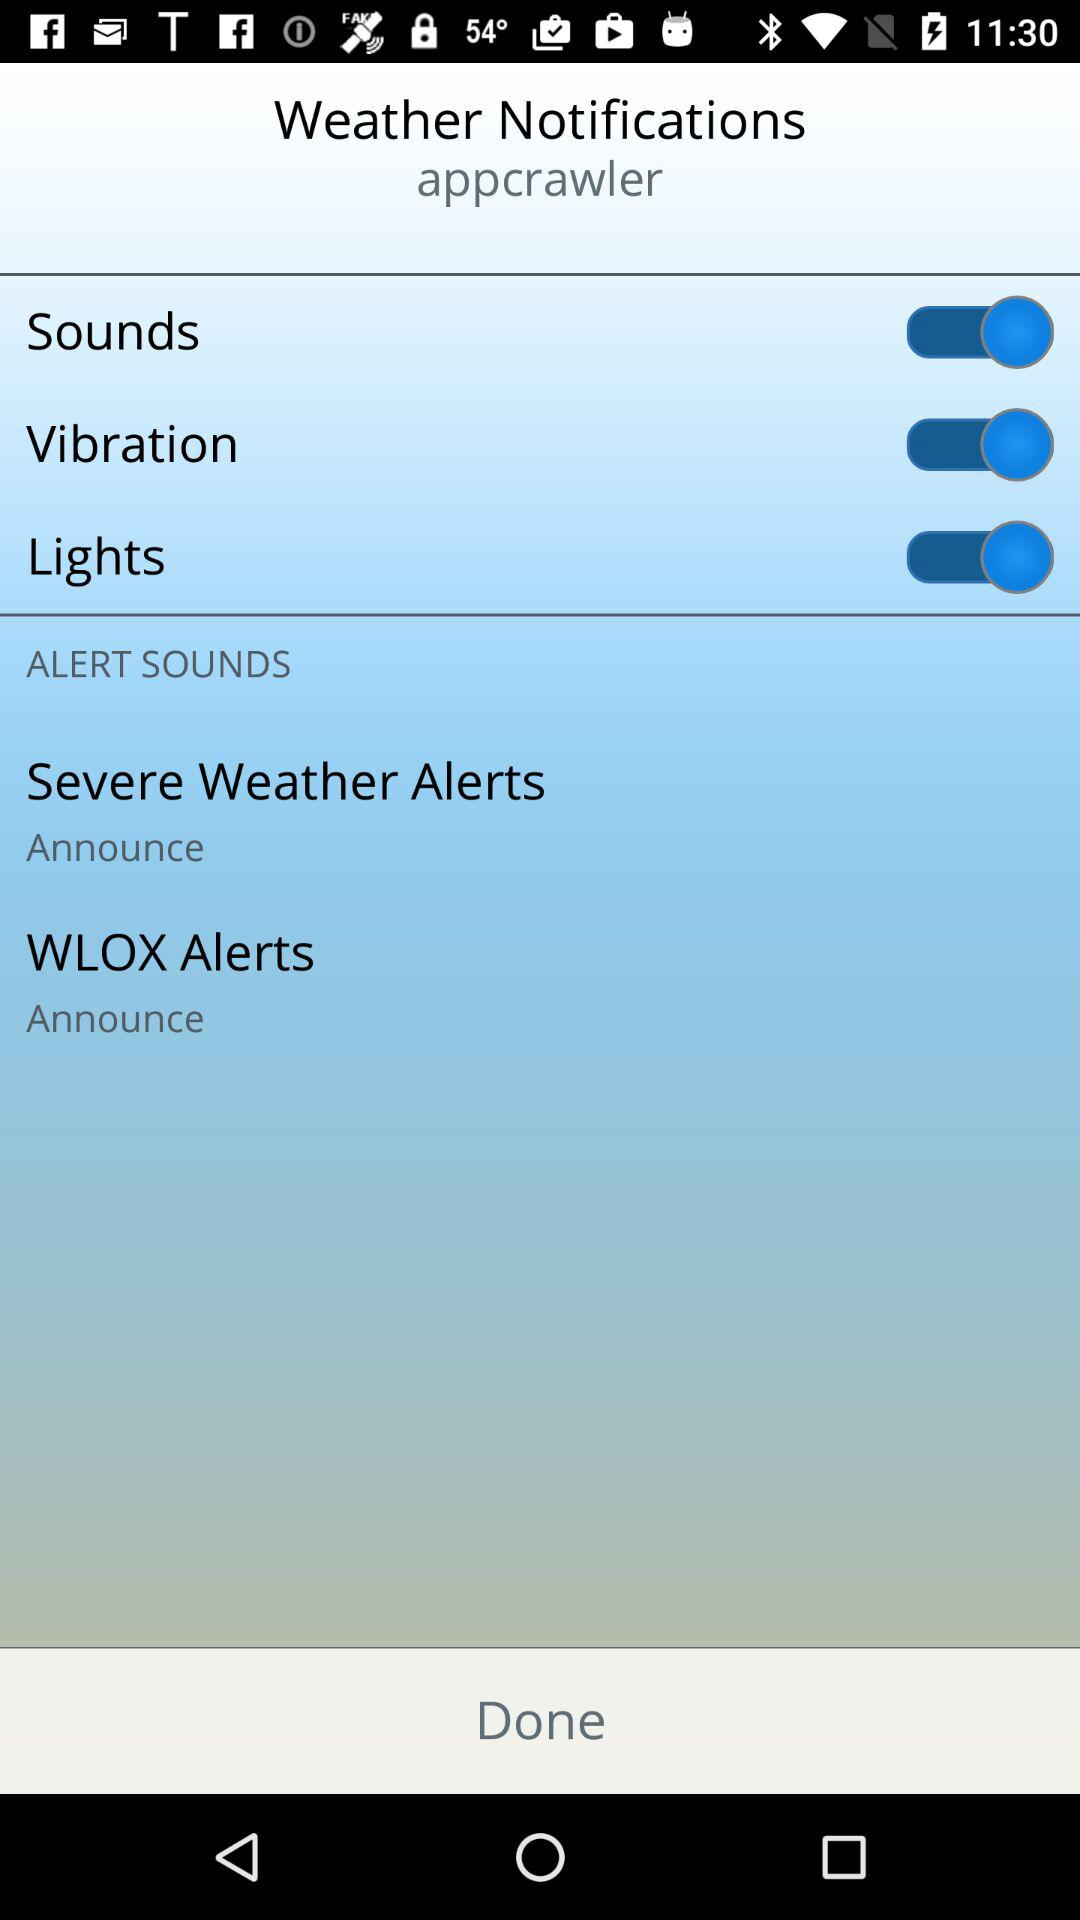How many alert options are there that have an announce checkbox?
Answer the question using a single word or phrase. 2 